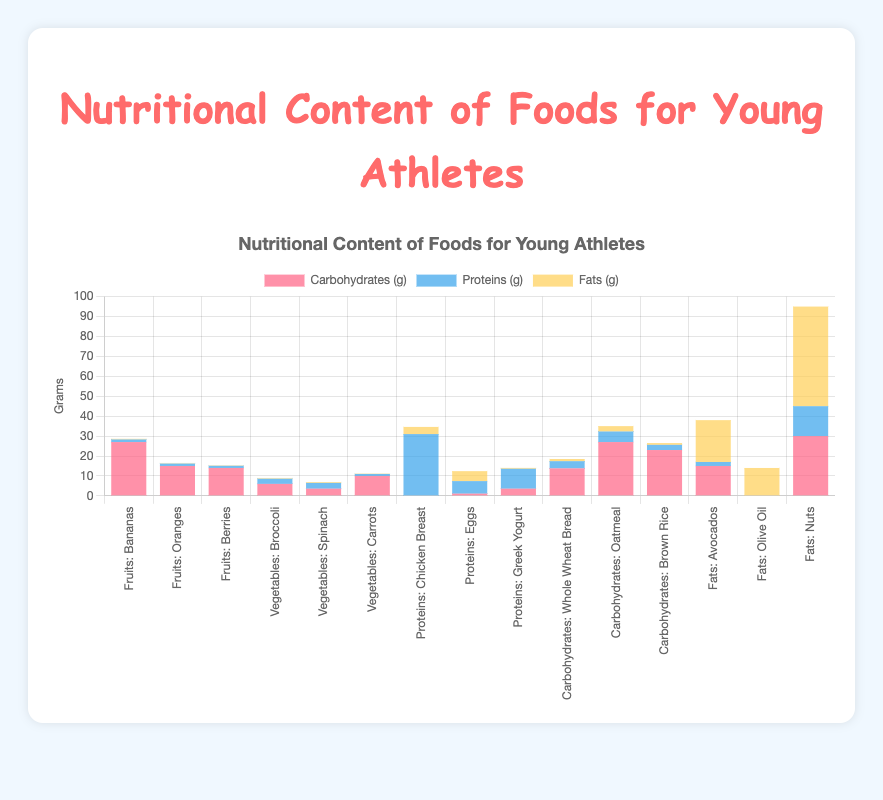How much protein does Chicken Breast provide compared to Nuts? Chicken Breast provides 31 grams of protein, while Nuts provide 15 grams of protein. Therefore, Chicken Breast provides 31 - 15 = 16 grams more protein than Nuts.
Answer: 16 grams Which food has the highest amount of carbohydrates? By observing the bar chart, the food item with the tallest red part in the bar represents the highest amount of carbohydrates. In this case, Nuts have 30 grams of carbohydrates, which is the highest among all food items.
Answer: Nuts What combination of foods will provide a total of around 15 grams of fats? By looking at the bars for each food item, Avocados have 21 grams of fats, which is higher than 15 grams itself. Olive Oil has 14 grams of fats, and by summing these grams, it exceeds 15 grams. Check Eggs (5 grams) and Greek Yogurt (0.4 grams), summing these (5 + 0.4) = 5.4 grams, which are still lower. Therefore, Nut (50 grams) will be over as well. For exact 15 grams, choosing Olive Oil (14 grams) plus a little amount of Greek Yogurt (1 gram) might fit better.
Answer: Olive Oil + some Greek Yogurt Which category provides the highest average amount of proteins? Calculate the average protein for each category. For Fruits, (1.3 + 1.2 + 1.1)/3 = 1.2 grams. For Vegetables, (2.6 + 2.9 + 1)/3 ≈ 2.17 grams. For Proteins, (31 + 6.3 + 10)/3 ≈ 15.77 grams. For Carbohydrates, (3.6 + 5.3 + 2.6)/3 ≈ 3.83 grams. For Fats, (2 + 0 + 15)/3 = 5.67 grams. Therefore, the average protein is highest in the Proteins category.
Answer: Proteins What is the total amount of vitamins and minerals provided by Oatmeal? According to the data, Oatmeal provides Fiber, Manganese, and Phosphorus, summing to 3 total vitamins & minerals.
Answer: 3 